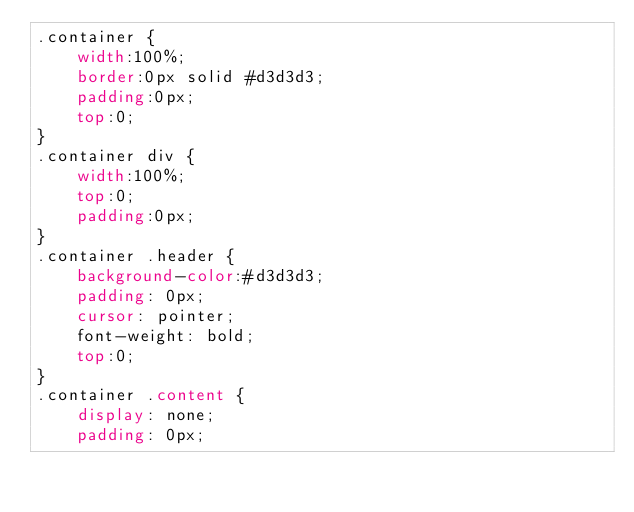Convert code to text. <code><loc_0><loc_0><loc_500><loc_500><_CSS_>.container {
    width:100%;
    border:0px solid #d3d3d3;
    padding:0px;
    top:0;
}
.container div {
    width:100%;
    top:0;
    padding:0px;
}
.container .header {
    background-color:#d3d3d3;
    padding: 0px;
    cursor: pointer;
    font-weight: bold;
    top:0;
}
.container .content {
    display: none;
    padding: 0px;
</code> 